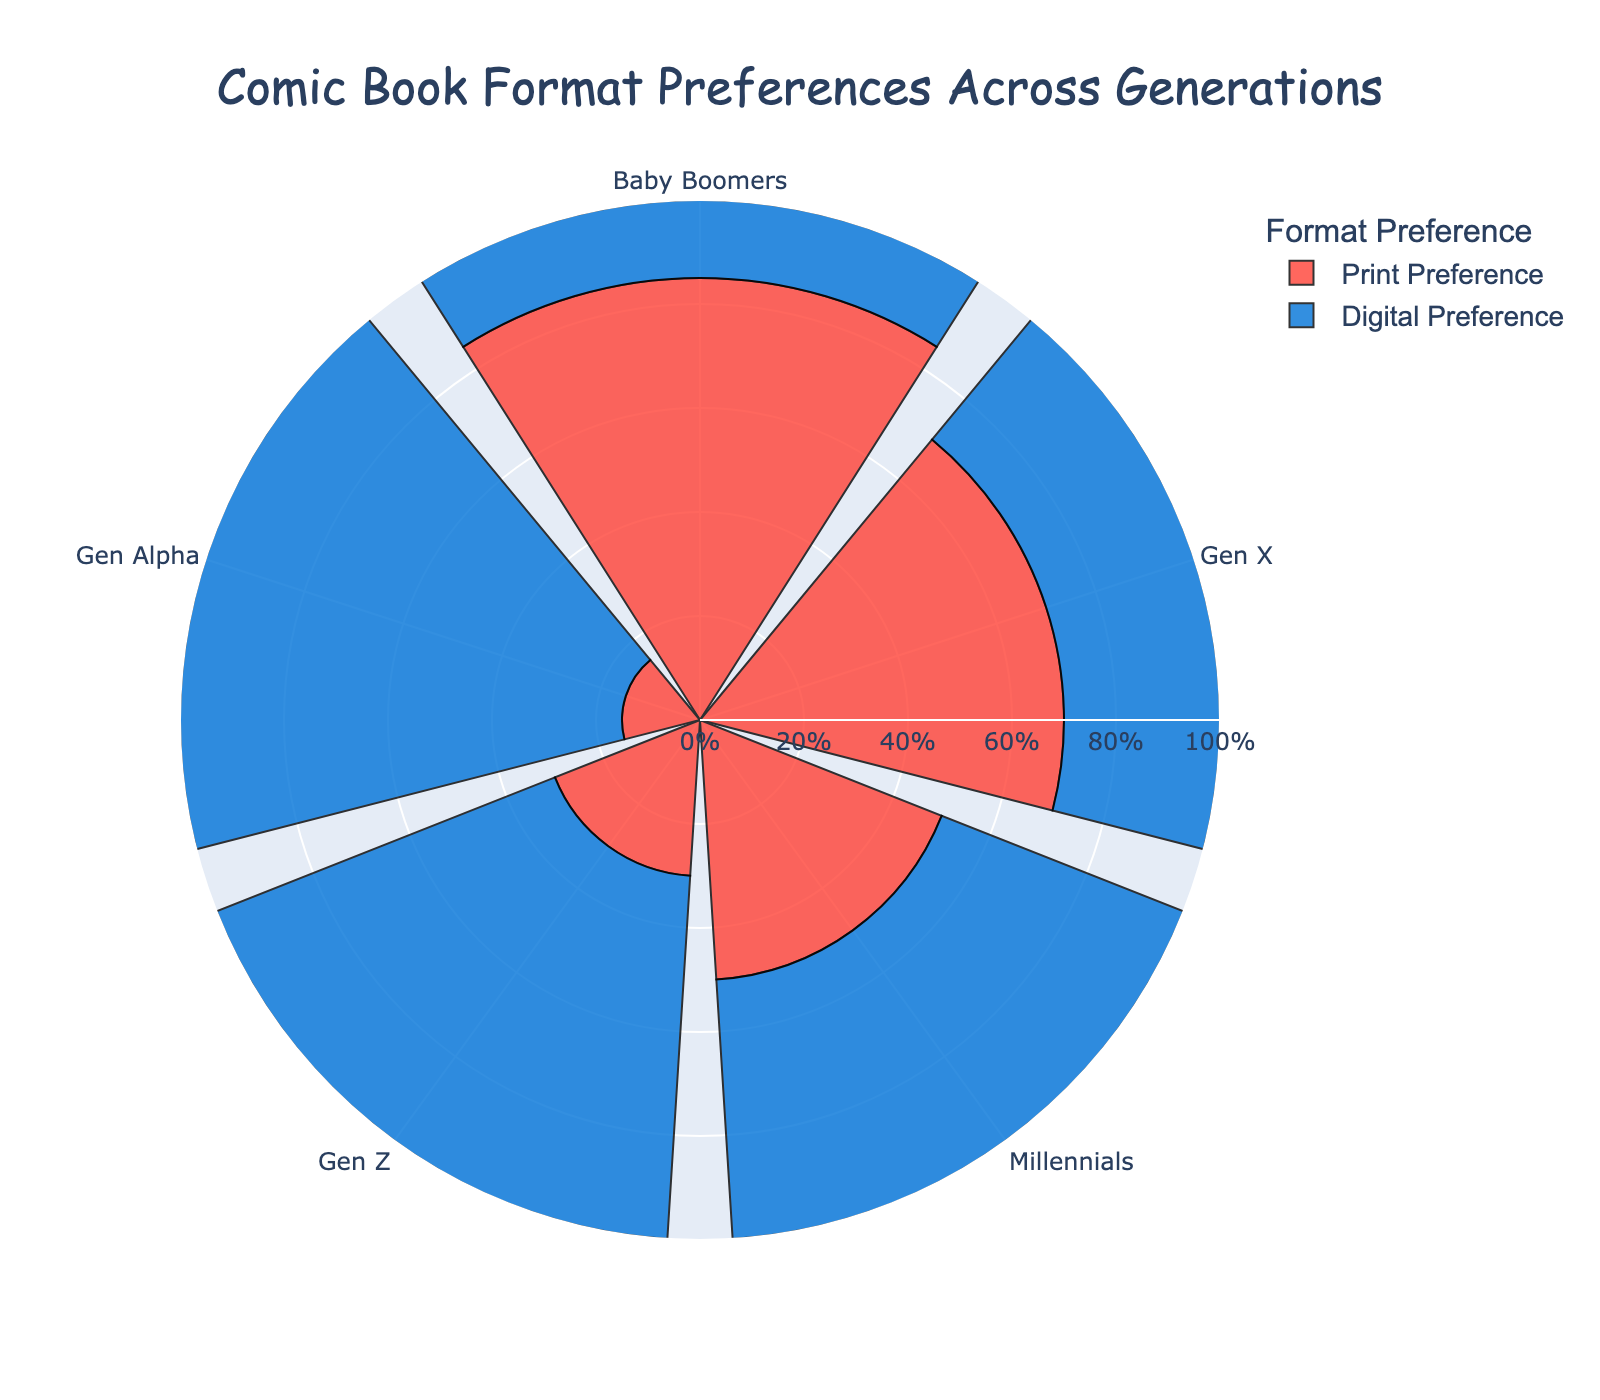What is the title of the chart? The title of the chart is displayed prominently at the top of the figure. It directly tells us what the chart is about.
Answer: Comic Book Format Preferences Across Generations How do Baby Boomers prefer to read their comic books? Look at the Baby Boomers bar in the chart and identify the taller section, which represents the format they prefer more.
Answer: Print Which generational group has the highest preference for digital comics? Compare the heights of the digital preference bars across all generations and identify the highest one.
Answer: Gen Alpha What is the difference in print preference between Gen X and Millennials? Look at the heights of the print preference bars for both Gen X and Millennials, then subtract the Millennial value from the Gen X value (70% - 50%).
Answer: 20% Is there an equal preference for print and digital comics within any generation? Identify the generation bar where the heights of both print and digital sections are equal.
Answer: Millennials What is the combined preference (in percentage) for digital comics for Gen Z and Gen Alpha? Sum the digital preference percentages of Gen Z and Gen Alpha (70% + 85%).
Answer: 155% Which generation shows the smallest percentage preference for print comics? Compare all the print preference bars and identify the smallest one.
Answer: Gen Alpha How does the preference for print comics change moving from Baby Boomers to Gen Alpha? Observe the trend in the heights of print preference bars from Baby Boomers to Gen Alpha to see if they increase, decrease, or remain the same.
Answer: Decrease Are younger generations more inclined towards digital comics compared to older generations? Compare the digital preference bars of younger generations (Gen Alpha, Gen Z) to those of older generations (Baby Boomers, Gen X).
Answer: Yes 